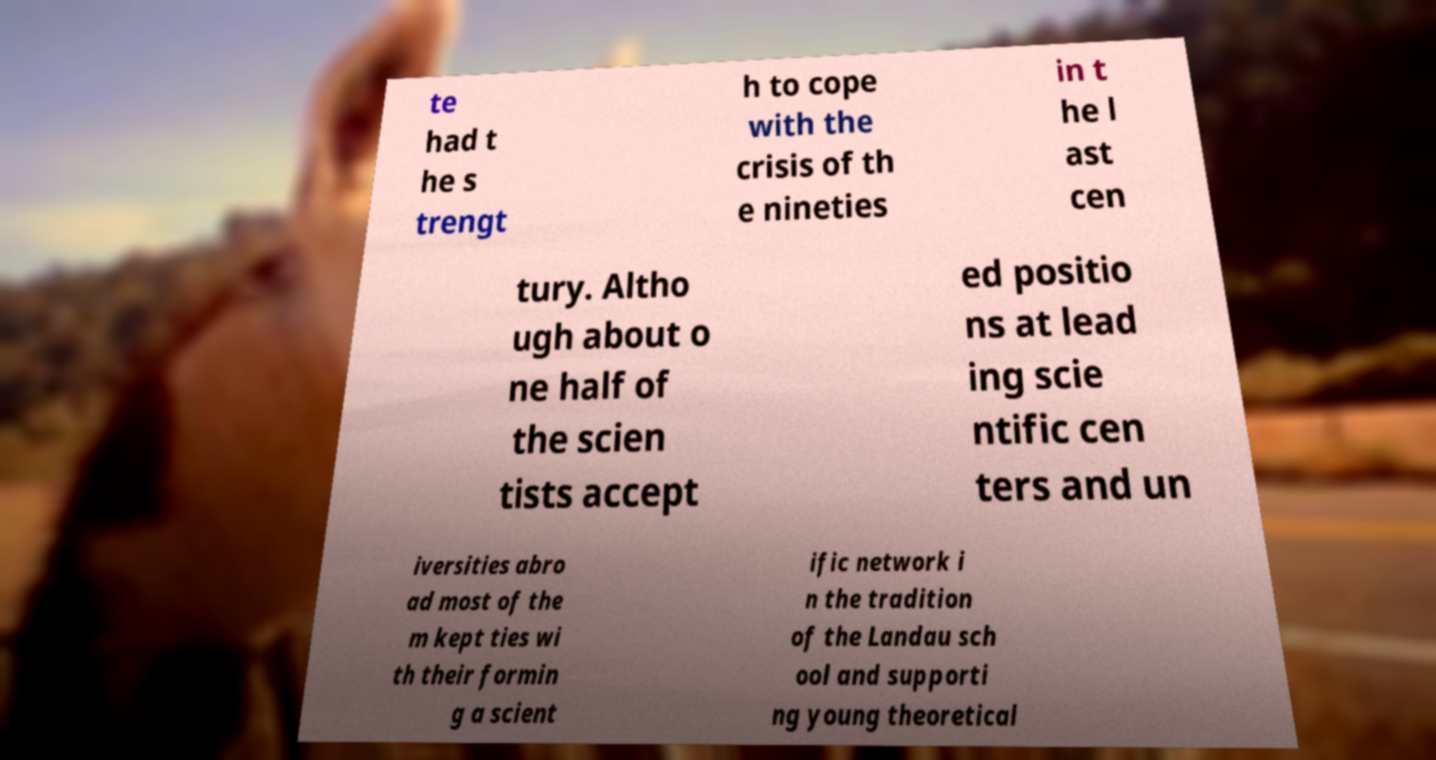I need the written content from this picture converted into text. Can you do that? te had t he s trengt h to cope with the crisis of th e nineties in t he l ast cen tury. Altho ugh about o ne half of the scien tists accept ed positio ns at lead ing scie ntific cen ters and un iversities abro ad most of the m kept ties wi th their formin g a scient ific network i n the tradition of the Landau sch ool and supporti ng young theoretical 